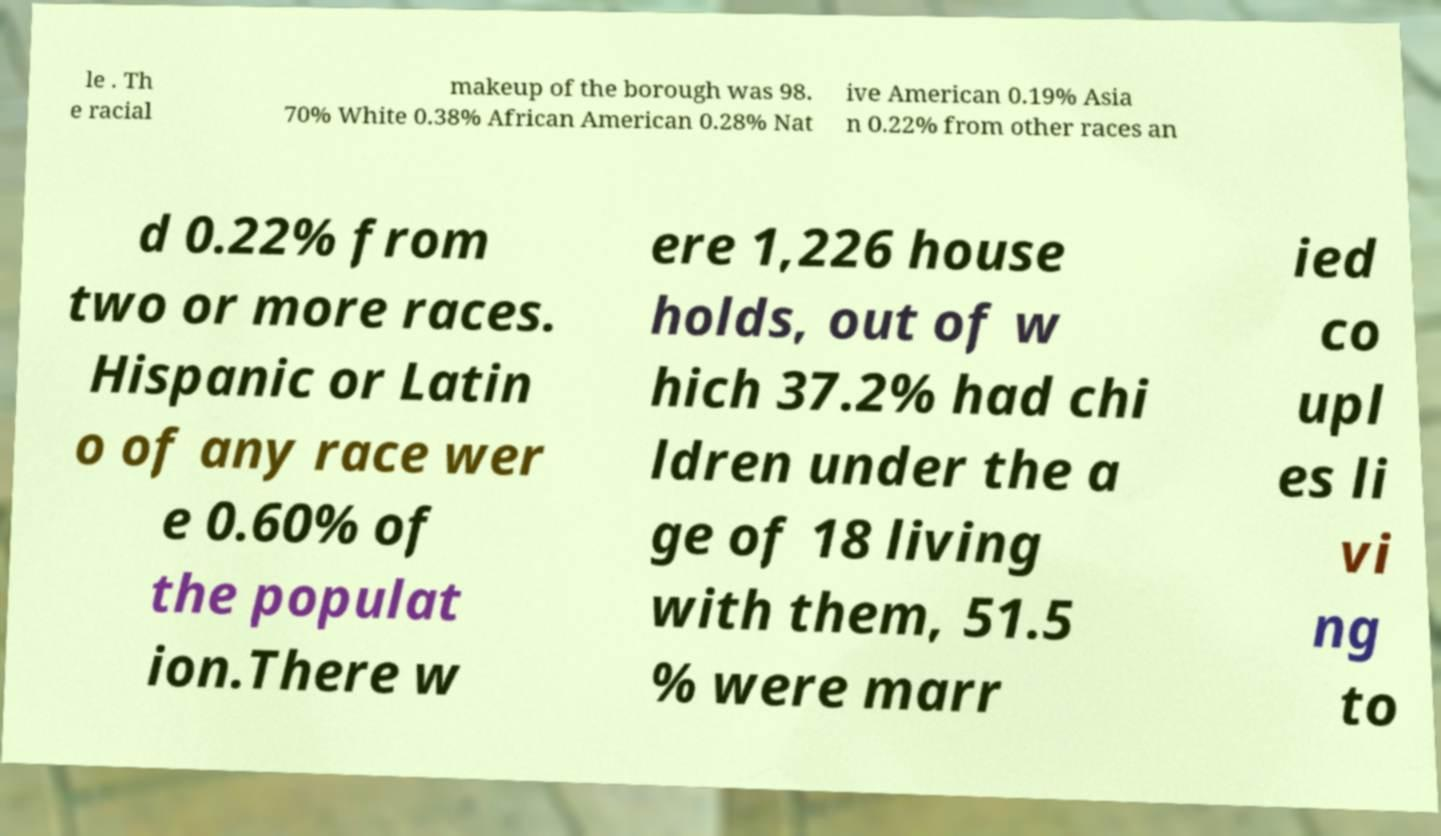Please identify and transcribe the text found in this image. le . Th e racial makeup of the borough was 98. 70% White 0.38% African American 0.28% Nat ive American 0.19% Asia n 0.22% from other races an d 0.22% from two or more races. Hispanic or Latin o of any race wer e 0.60% of the populat ion.There w ere 1,226 house holds, out of w hich 37.2% had chi ldren under the a ge of 18 living with them, 51.5 % were marr ied co upl es li vi ng to 